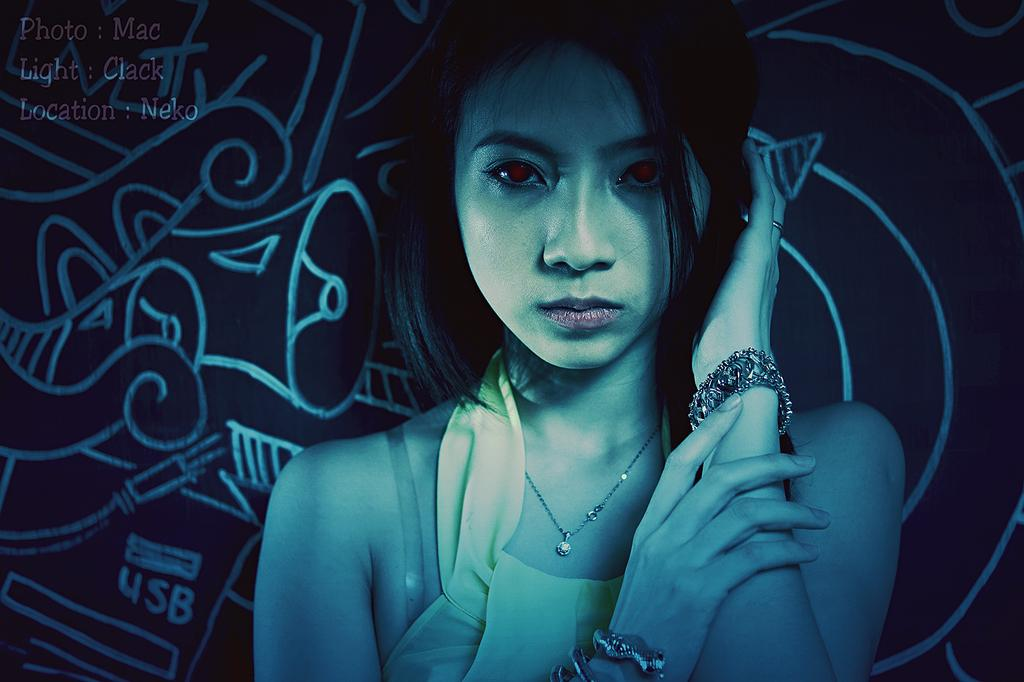What is the main subject of the image? The main subject of the image is a woman. Can you describe the background of the image? There is a wall visible behind the woman in the image. What type of learning is the woman engaged in while standing in front of the wall? There is no indication in the image that the woman is engaged in any learning activity. 